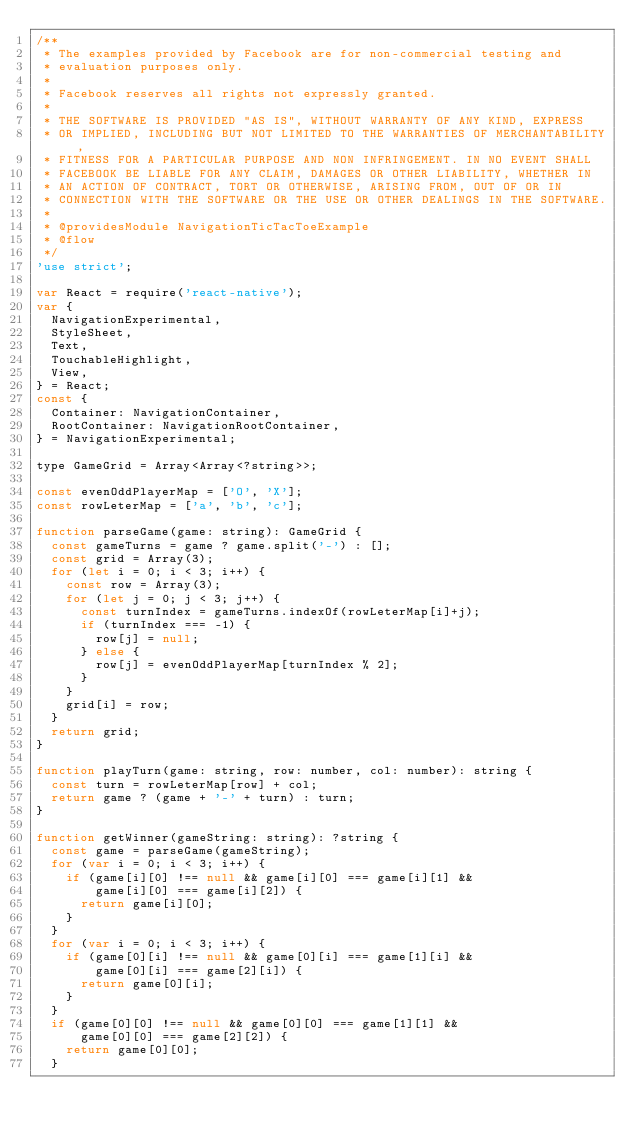Convert code to text. <code><loc_0><loc_0><loc_500><loc_500><_JavaScript_>/**
 * The examples provided by Facebook are for non-commercial testing and
 * evaluation purposes only.
 *
 * Facebook reserves all rights not expressly granted.
 *
 * THE SOFTWARE IS PROVIDED "AS IS", WITHOUT WARRANTY OF ANY KIND, EXPRESS
 * OR IMPLIED, INCLUDING BUT NOT LIMITED TO THE WARRANTIES OF MERCHANTABILITY,
 * FITNESS FOR A PARTICULAR PURPOSE AND NON INFRINGEMENT. IN NO EVENT SHALL
 * FACEBOOK BE LIABLE FOR ANY CLAIM, DAMAGES OR OTHER LIABILITY, WHETHER IN
 * AN ACTION OF CONTRACT, TORT OR OTHERWISE, ARISING FROM, OUT OF OR IN
 * CONNECTION WITH THE SOFTWARE OR THE USE OR OTHER DEALINGS IN THE SOFTWARE.
 *
 * @providesModule NavigationTicTacToeExample
 * @flow
 */
'use strict';

var React = require('react-native');
var {
  NavigationExperimental,
  StyleSheet,
  Text,
  TouchableHighlight,
  View,
} = React;
const {
  Container: NavigationContainer,
  RootContainer: NavigationRootContainer,
} = NavigationExperimental;

type GameGrid = Array<Array<?string>>;

const evenOddPlayerMap = ['O', 'X'];
const rowLeterMap = ['a', 'b', 'c'];

function parseGame(game: string): GameGrid {
  const gameTurns = game ? game.split('-') : [];
  const grid = Array(3);
  for (let i = 0; i < 3; i++) {
    const row = Array(3);
    for (let j = 0; j < 3; j++) {
      const turnIndex = gameTurns.indexOf(rowLeterMap[i]+j);
      if (turnIndex === -1) {
        row[j] = null;
      } else {
        row[j] = evenOddPlayerMap[turnIndex % 2];
      }
    }
    grid[i] = row;
  }
  return grid;
}

function playTurn(game: string, row: number, col: number): string {
  const turn = rowLeterMap[row] + col;
  return game ? (game + '-' + turn) : turn;
}

function getWinner(gameString: string): ?string {
  const game = parseGame(gameString);
  for (var i = 0; i < 3; i++) {
    if (game[i][0] !== null && game[i][0] === game[i][1] &&
        game[i][0] === game[i][2]) {
      return game[i][0];
    }
  }
  for (var i = 0; i < 3; i++) {
    if (game[0][i] !== null && game[0][i] === game[1][i] &&
        game[0][i] === game[2][i]) {
      return game[0][i];
    }
  }
  if (game[0][0] !== null && game[0][0] === game[1][1] &&
      game[0][0] === game[2][2]) {
    return game[0][0];
  }</code> 